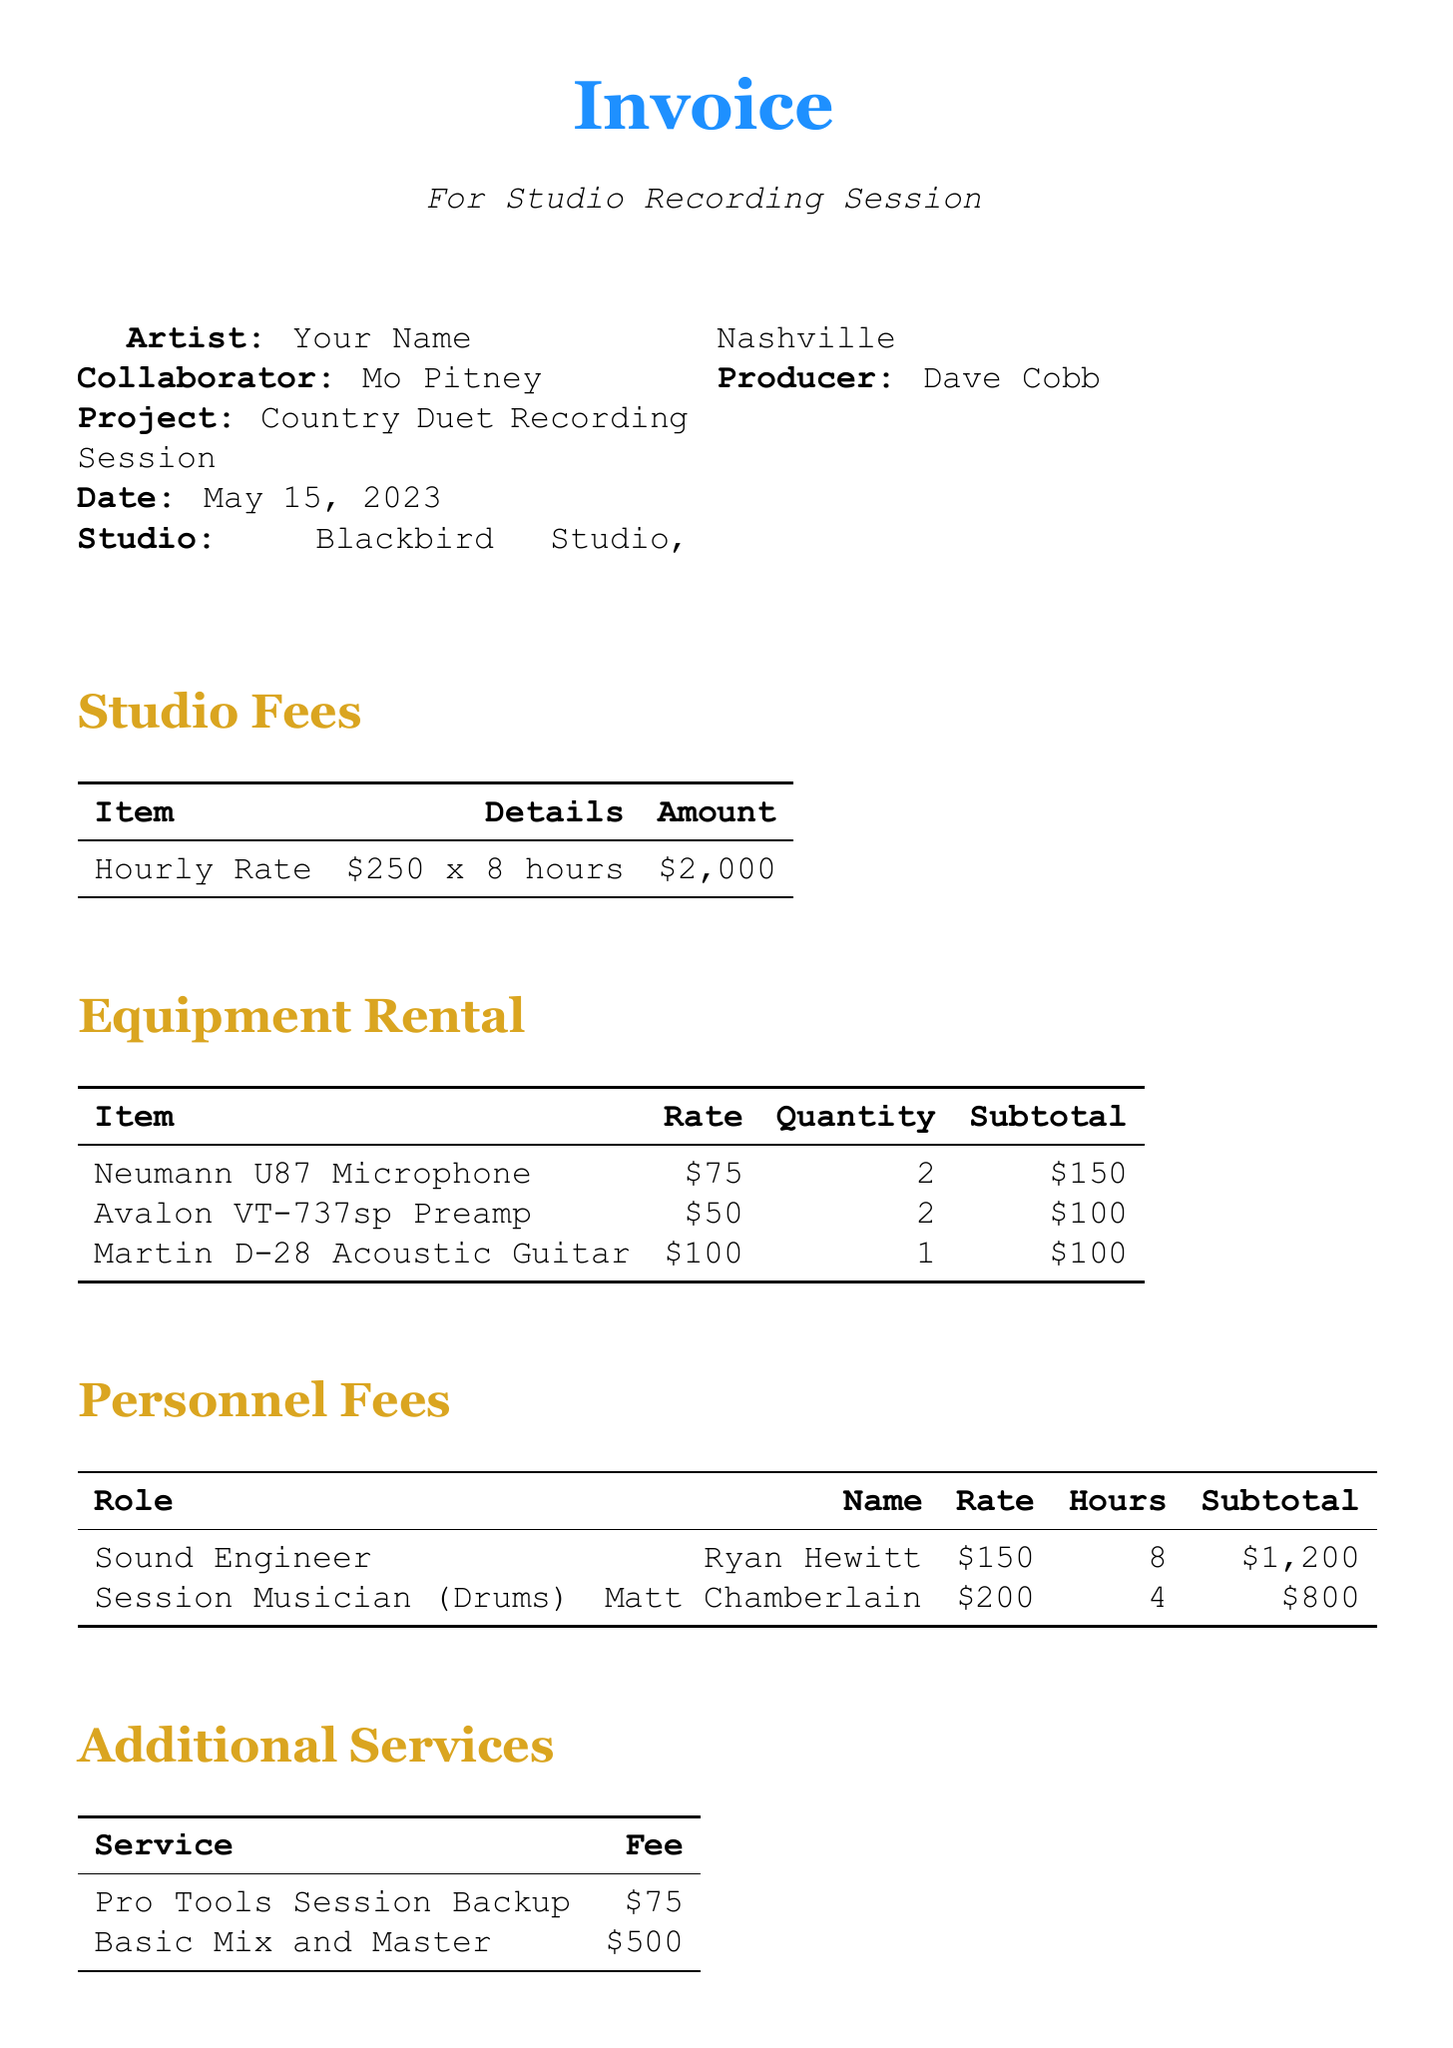What is the artist's name? The artist's name is listed at the beginning of the document under Invoice details.
Answer: Your Name What is the collaborator's name? The collaborator's name appears alongside the artist's name in the invoice details.
Answer: Mo Pitney What is the date of the recording session? The date is provided in the document under the project details section.
Answer: May 15, 2023 How many hours were booked for the studio session? The number of hours booked is specified in the studio fees section of the document.
Answer: 8 What is the total due amount? The total due is indicated in the final section of the invoice.
Answer: $5,100 Who is the sound engineer? The sound engineer's name is given in the personnel fees section.
Answer: Ryan Hewitt What is the subtotal for equipment rental? The subtotal for equipment rental is calculated from the individual item costs listed in the document.
Answer: $350 How much was paid for catering? The catering expense is listed in the expenses section of the invoice.
Answer: $150 What services were included under additional services? The additional services are detailed in a specific section with their associated fees.
Answer: Pro Tools Session Backup, Basic Mix and Master 